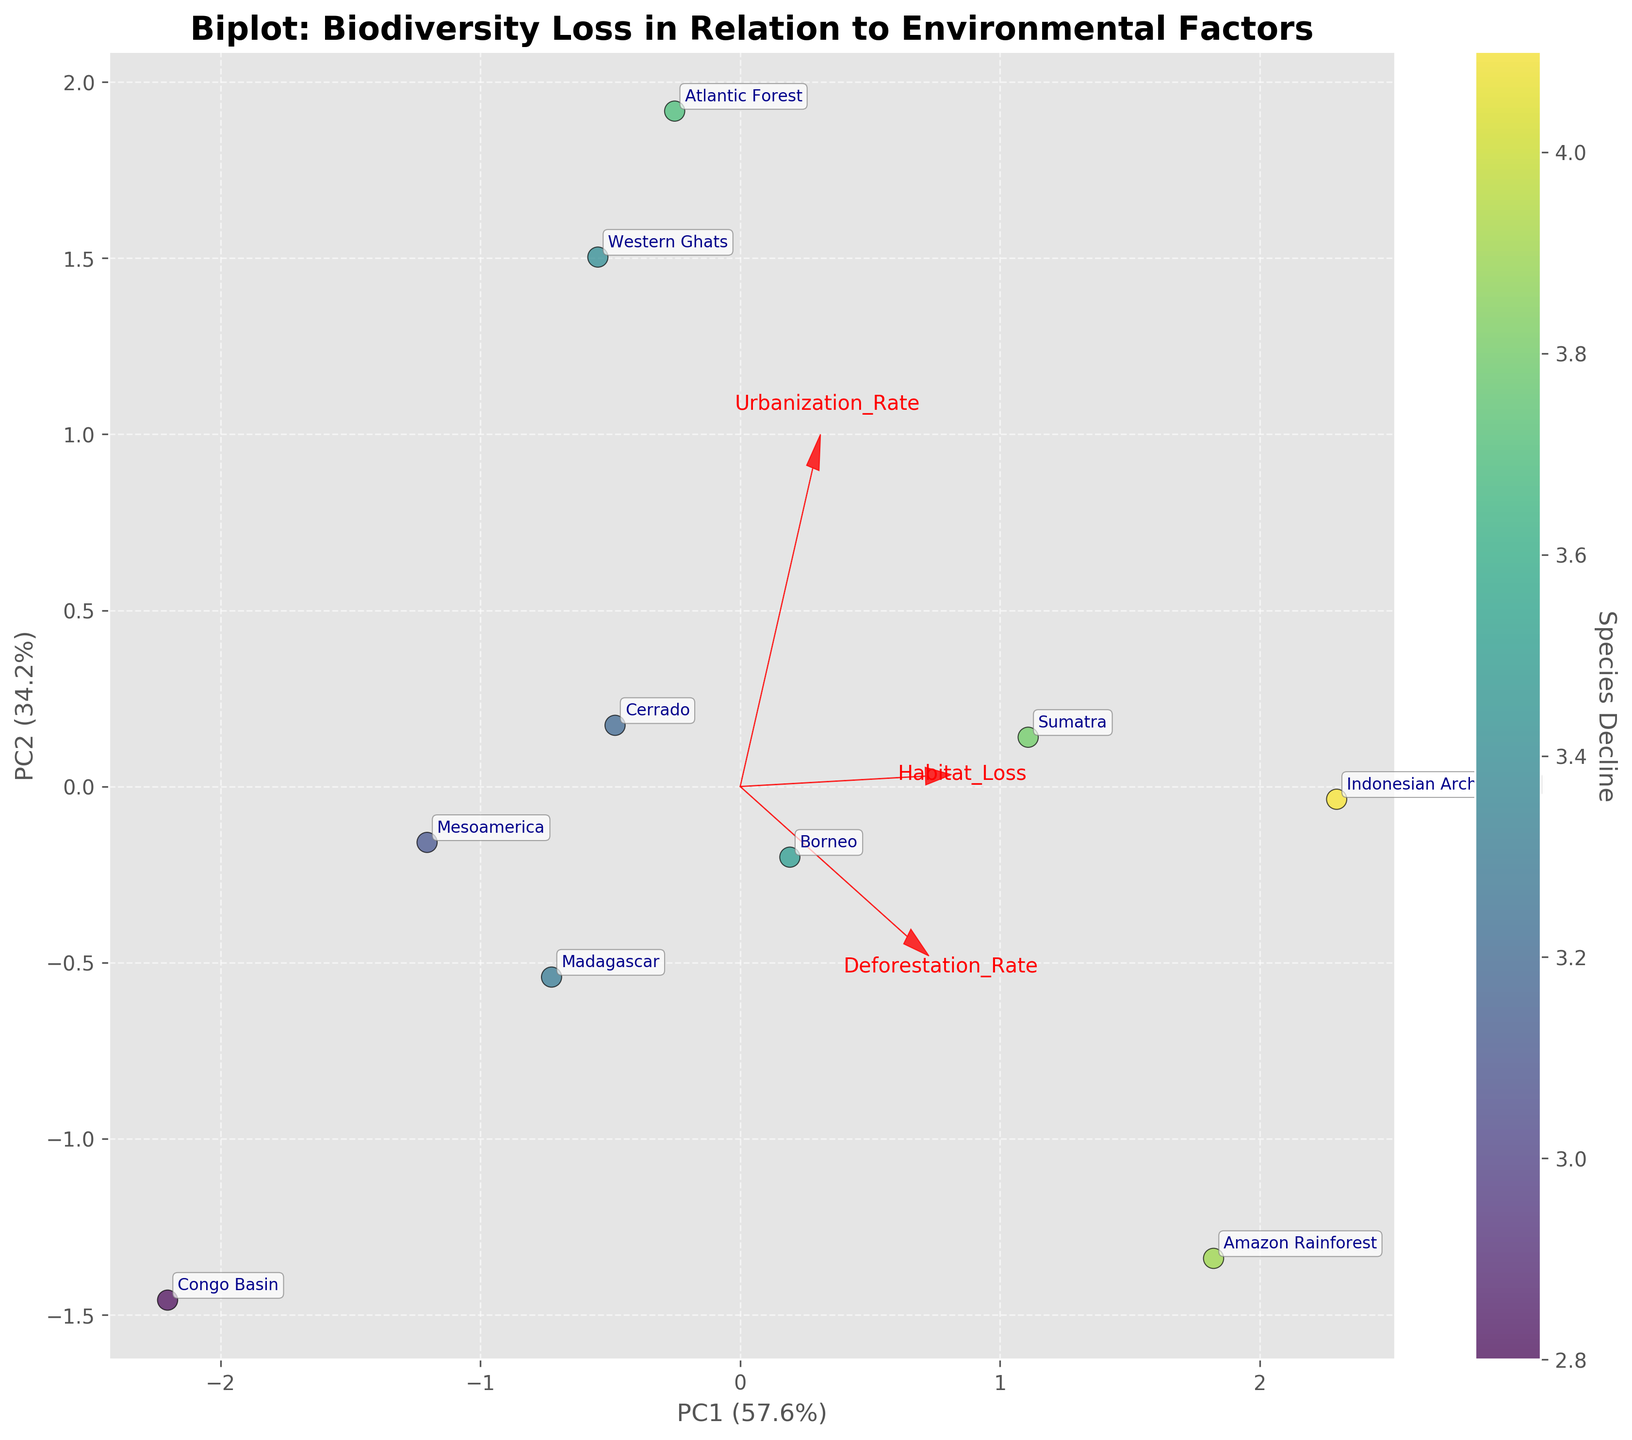What is the title of the biplot? The biplot has a clearly written title at the top center. Reading the title, we see "Biplot: Biodiversity Loss in Relation to Environmental Factors."
Answer: Biplot: Biodiversity Loss in Relation to Environmental Factors How many principal components are shown in the biplot? The biplot displays two axes labeled as "PC1" and "PC2," indicating that two principal components are shown.
Answer: 2 Which region has the highest species decline? The scatter plot colors indicate species decline, where darker colors represent higher declines. By comparing the color shades, "Indonesian Archipelago" has the darkest color.
Answer: Indonesian Archipelago What percent of variance is explained by PC1 and PC2 combined? Looking at the x and y axis labels, PC1 explains 57.9% and PC2 explains 25.3% of the variance. Summing these values gives 57.9% + 25.3% = 83.2%.
Answer: 83.2% Which environmental factor is most strongly associated with PC1? The feature vector for "Habitat Loss" points heavily in the direction of the PC1 axis. This indicates a strong association.
Answer: Habitat Loss Which region has the highest score along PC2? Observing the positions of the points along the PC2 axis, 'Western Ghats' is positioned highest along this axis.
Answer: Western Ghats How does the deforestation rate relate to the PC1 score? The arrow for "Deforestation Rate" points in the same direction strongly as the PC1 axis, suggesting a positive correlation.
Answer: Positive correlation Which feature is most closely associated with the PC2 axis? The arrows depicting the features show that "Urbanization Rate" points strongly in the direction of the PC2 axis.
Answer: Urbanization Rate What is the relationship between "Deforestation Rate" and "Urbanization Rate"? Observing the directions of the vectors for "Deforestation Rate" and "Urbanization Rate," they are almost orthogonal. This implies there's little to no direct correlation.
Answer: Little correlation Which regions' positions suggest they experience moderate habitat loss? Points closer to the middle of the arrows represent moderate values. "Congo Basin" and "Mesoamerica" are centrally located near the middle of the "Habitat Loss" axis.
Answer: Congo Basin and Mesoamerica 